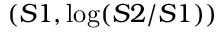<formula> <loc_0><loc_0><loc_500><loc_500>( S 1 , \log ( S 2 / S 1 ) )</formula> 